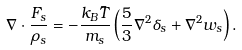<formula> <loc_0><loc_0><loc_500><loc_500>\nabla \cdot \frac { F _ { s } } { \rho _ { s } } = - \frac { k _ { B } \bar { T } } { m _ { s } } \left ( \frac { 5 } { 3 } \nabla ^ { 2 } \delta _ { s } + \nabla ^ { 2 } w _ { s } \right ) .</formula> 